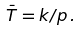<formula> <loc_0><loc_0><loc_500><loc_500>\bar { T } = k / p \, .</formula> 